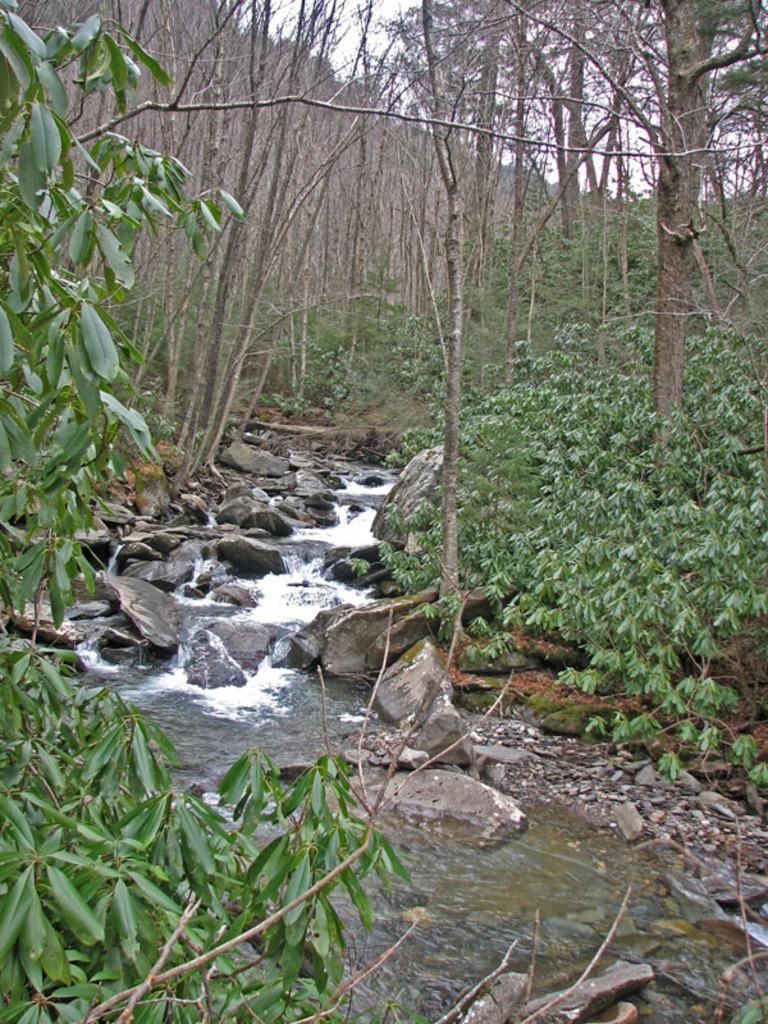Could you give a brief overview of what you see in this image? At the bottom of the image there is water and there are some stones. In the middle of the image there are some trees. Behind the trees there is sky. 